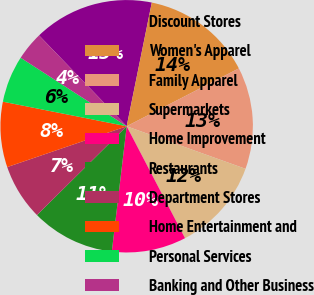Convert chart to OTSL. <chart><loc_0><loc_0><loc_500><loc_500><pie_chart><fcel>Discount Stores<fcel>Women's Apparel<fcel>Family Apparel<fcel>Supermarkets<fcel>Home Improvement<fcel>Restaurants<fcel>Department Stores<fcel>Home Entertainment and<fcel>Personal Services<fcel>Banking and Other Business<nl><fcel>15.4%<fcel>14.23%<fcel>13.05%<fcel>11.88%<fcel>9.53%<fcel>10.7%<fcel>7.18%<fcel>8.36%<fcel>6.01%<fcel>3.66%<nl></chart> 